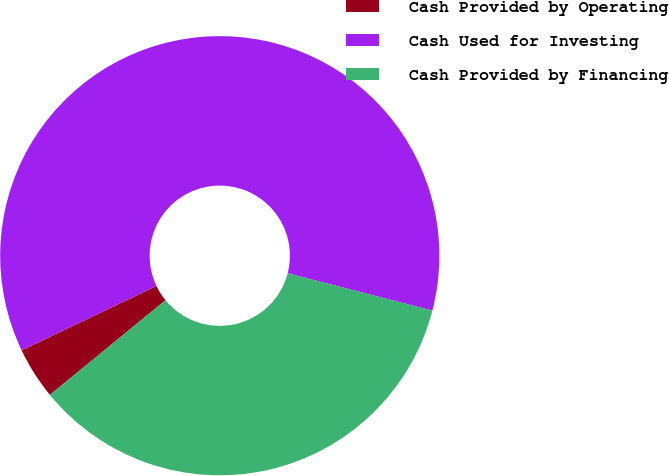Convert chart to OTSL. <chart><loc_0><loc_0><loc_500><loc_500><pie_chart><fcel>Cash Provided by Operating<fcel>Cash Used for Investing<fcel>Cash Provided by Financing<nl><fcel>3.84%<fcel>61.11%<fcel>35.05%<nl></chart> 